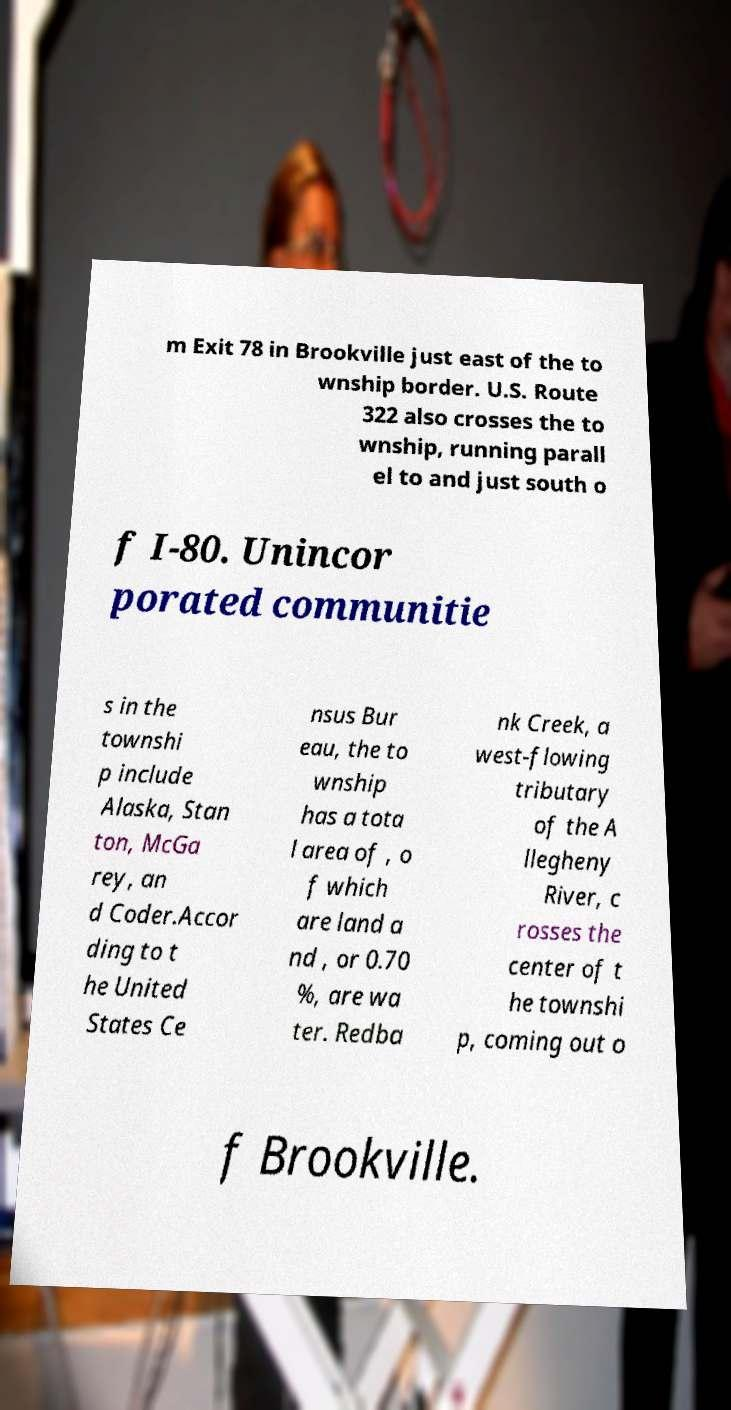There's text embedded in this image that I need extracted. Can you transcribe it verbatim? m Exit 78 in Brookville just east of the to wnship border. U.S. Route 322 also crosses the to wnship, running parall el to and just south o f I-80. Unincor porated communitie s in the townshi p include Alaska, Stan ton, McGa rey, an d Coder.Accor ding to t he United States Ce nsus Bur eau, the to wnship has a tota l area of , o f which are land a nd , or 0.70 %, are wa ter. Redba nk Creek, a west-flowing tributary of the A llegheny River, c rosses the center of t he townshi p, coming out o f Brookville. 